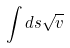Convert formula to latex. <formula><loc_0><loc_0><loc_500><loc_500>\int d s \sqrt { v }</formula> 